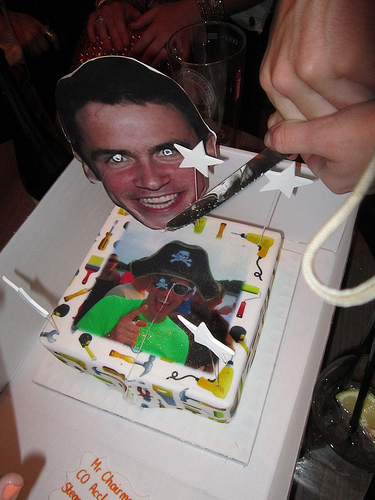Can you comment on any unique decorative elements seen on the cake? Certainly, there are several unique decorations including a cutout of a grinning face, a pair of white star decorations, and an intriguing pirate image, all of which add to the customized and whimsical nature of the cake. Are there any other items in the image that suggest this is a social event? Beyond the decorative cake, one can see pieces of a festive banner and what appears to be a hand with a party horn, all elements suggesting the image was taken during a social celebration. 